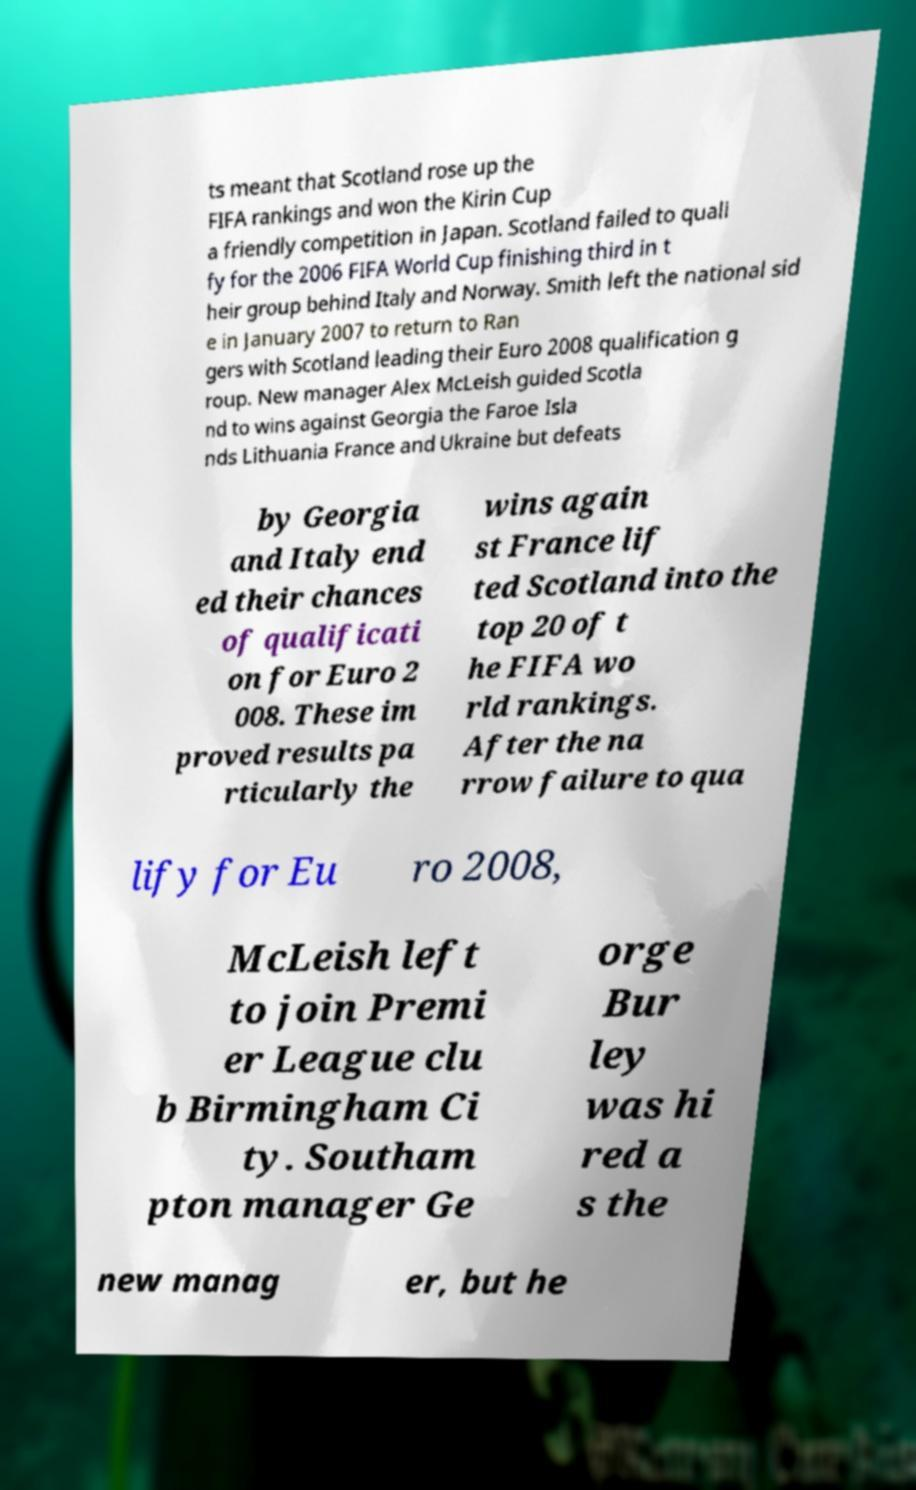I need the written content from this picture converted into text. Can you do that? ts meant that Scotland rose up the FIFA rankings and won the Kirin Cup a friendly competition in Japan. Scotland failed to quali fy for the 2006 FIFA World Cup finishing third in t heir group behind Italy and Norway. Smith left the national sid e in January 2007 to return to Ran gers with Scotland leading their Euro 2008 qualification g roup. New manager Alex McLeish guided Scotla nd to wins against Georgia the Faroe Isla nds Lithuania France and Ukraine but defeats by Georgia and Italy end ed their chances of qualificati on for Euro 2 008. These im proved results pa rticularly the wins again st France lif ted Scotland into the top 20 of t he FIFA wo rld rankings. After the na rrow failure to qua lify for Eu ro 2008, McLeish left to join Premi er League clu b Birmingham Ci ty. Southam pton manager Ge orge Bur ley was hi red a s the new manag er, but he 